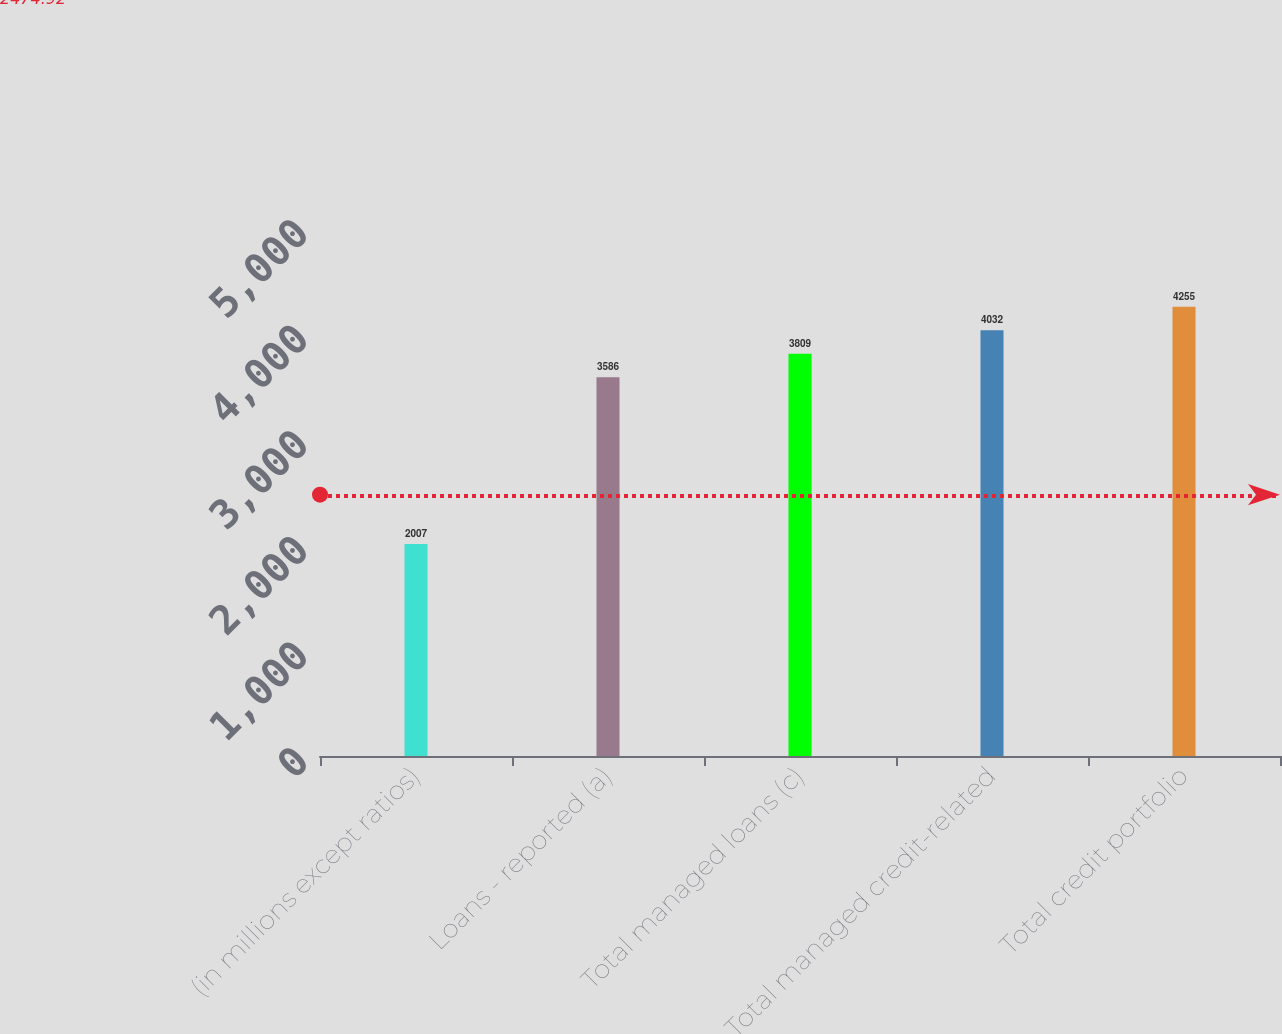<chart> <loc_0><loc_0><loc_500><loc_500><bar_chart><fcel>(in millions except ratios)<fcel>Loans - reported (a)<fcel>Total managed loans (c)<fcel>Total managed credit-related<fcel>Total credit portfolio<nl><fcel>2007<fcel>3586<fcel>3809<fcel>4032<fcel>4255<nl></chart> 